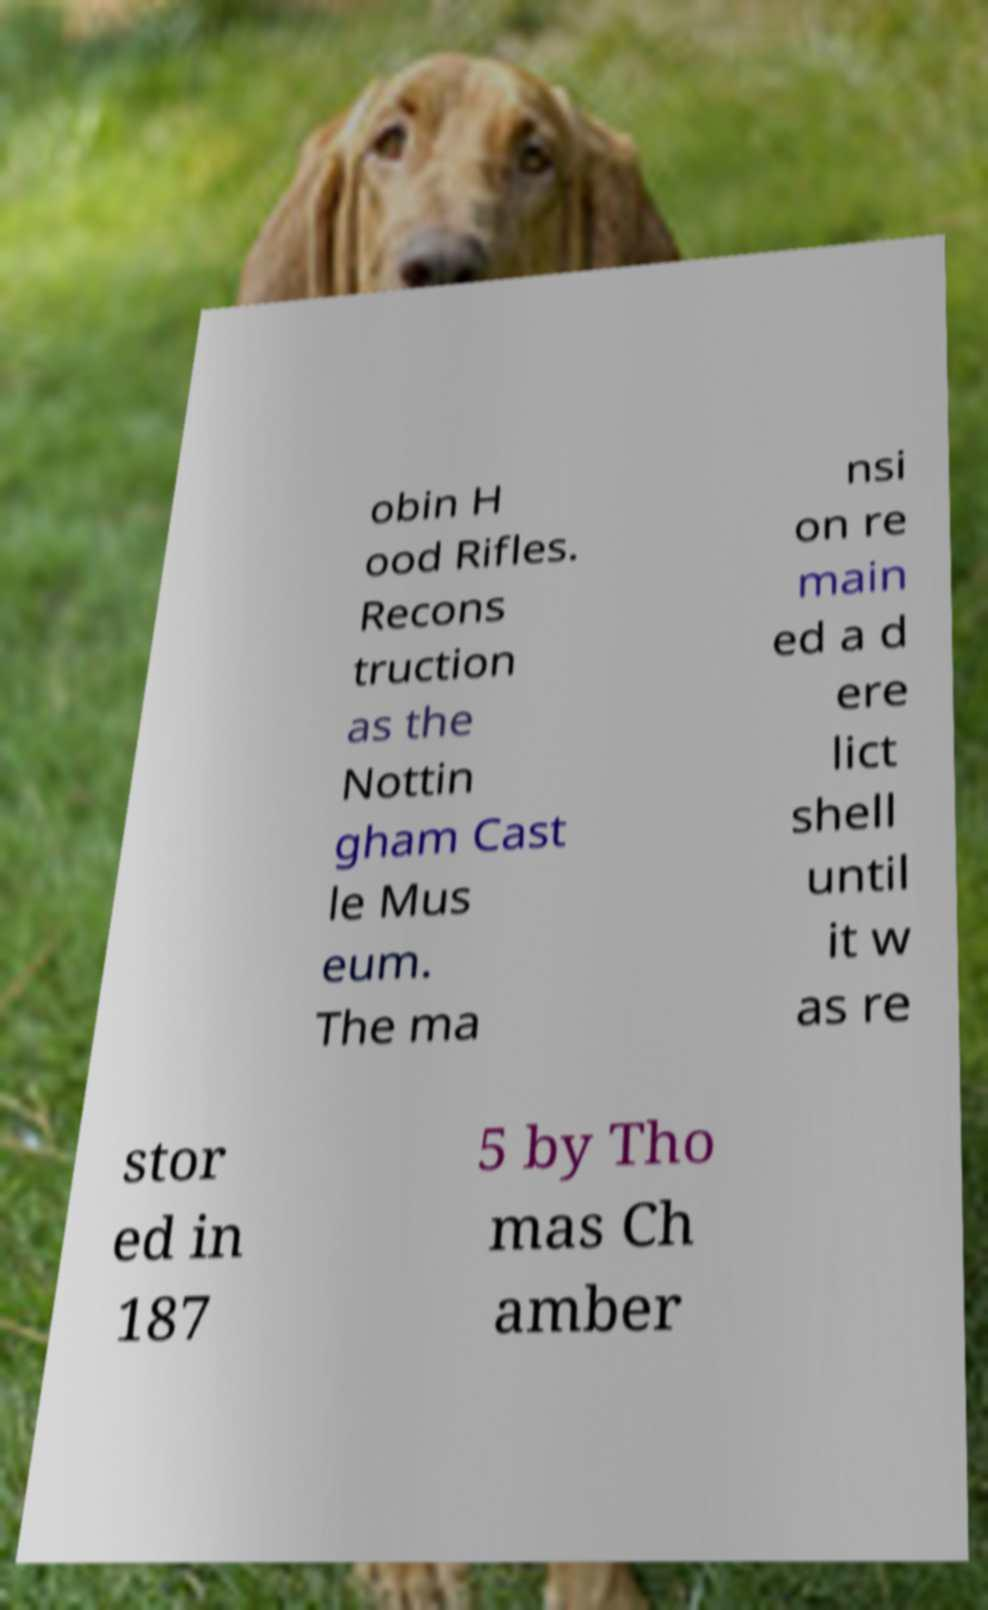For documentation purposes, I need the text within this image transcribed. Could you provide that? obin H ood Rifles. Recons truction as the Nottin gham Cast le Mus eum. The ma nsi on re main ed a d ere lict shell until it w as re stor ed in 187 5 by Tho mas Ch amber 